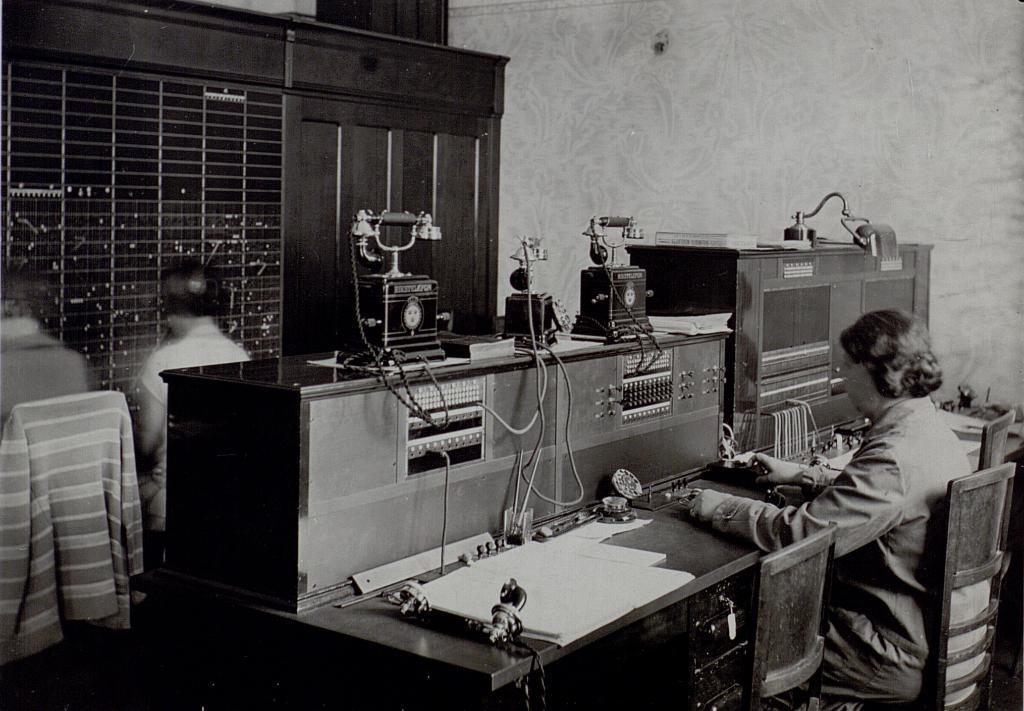Could you give a brief overview of what you see in this image? These persons are sitting on the chair. We can see table. On the table we can see telephone,paper and things. On the background we can see wall. 